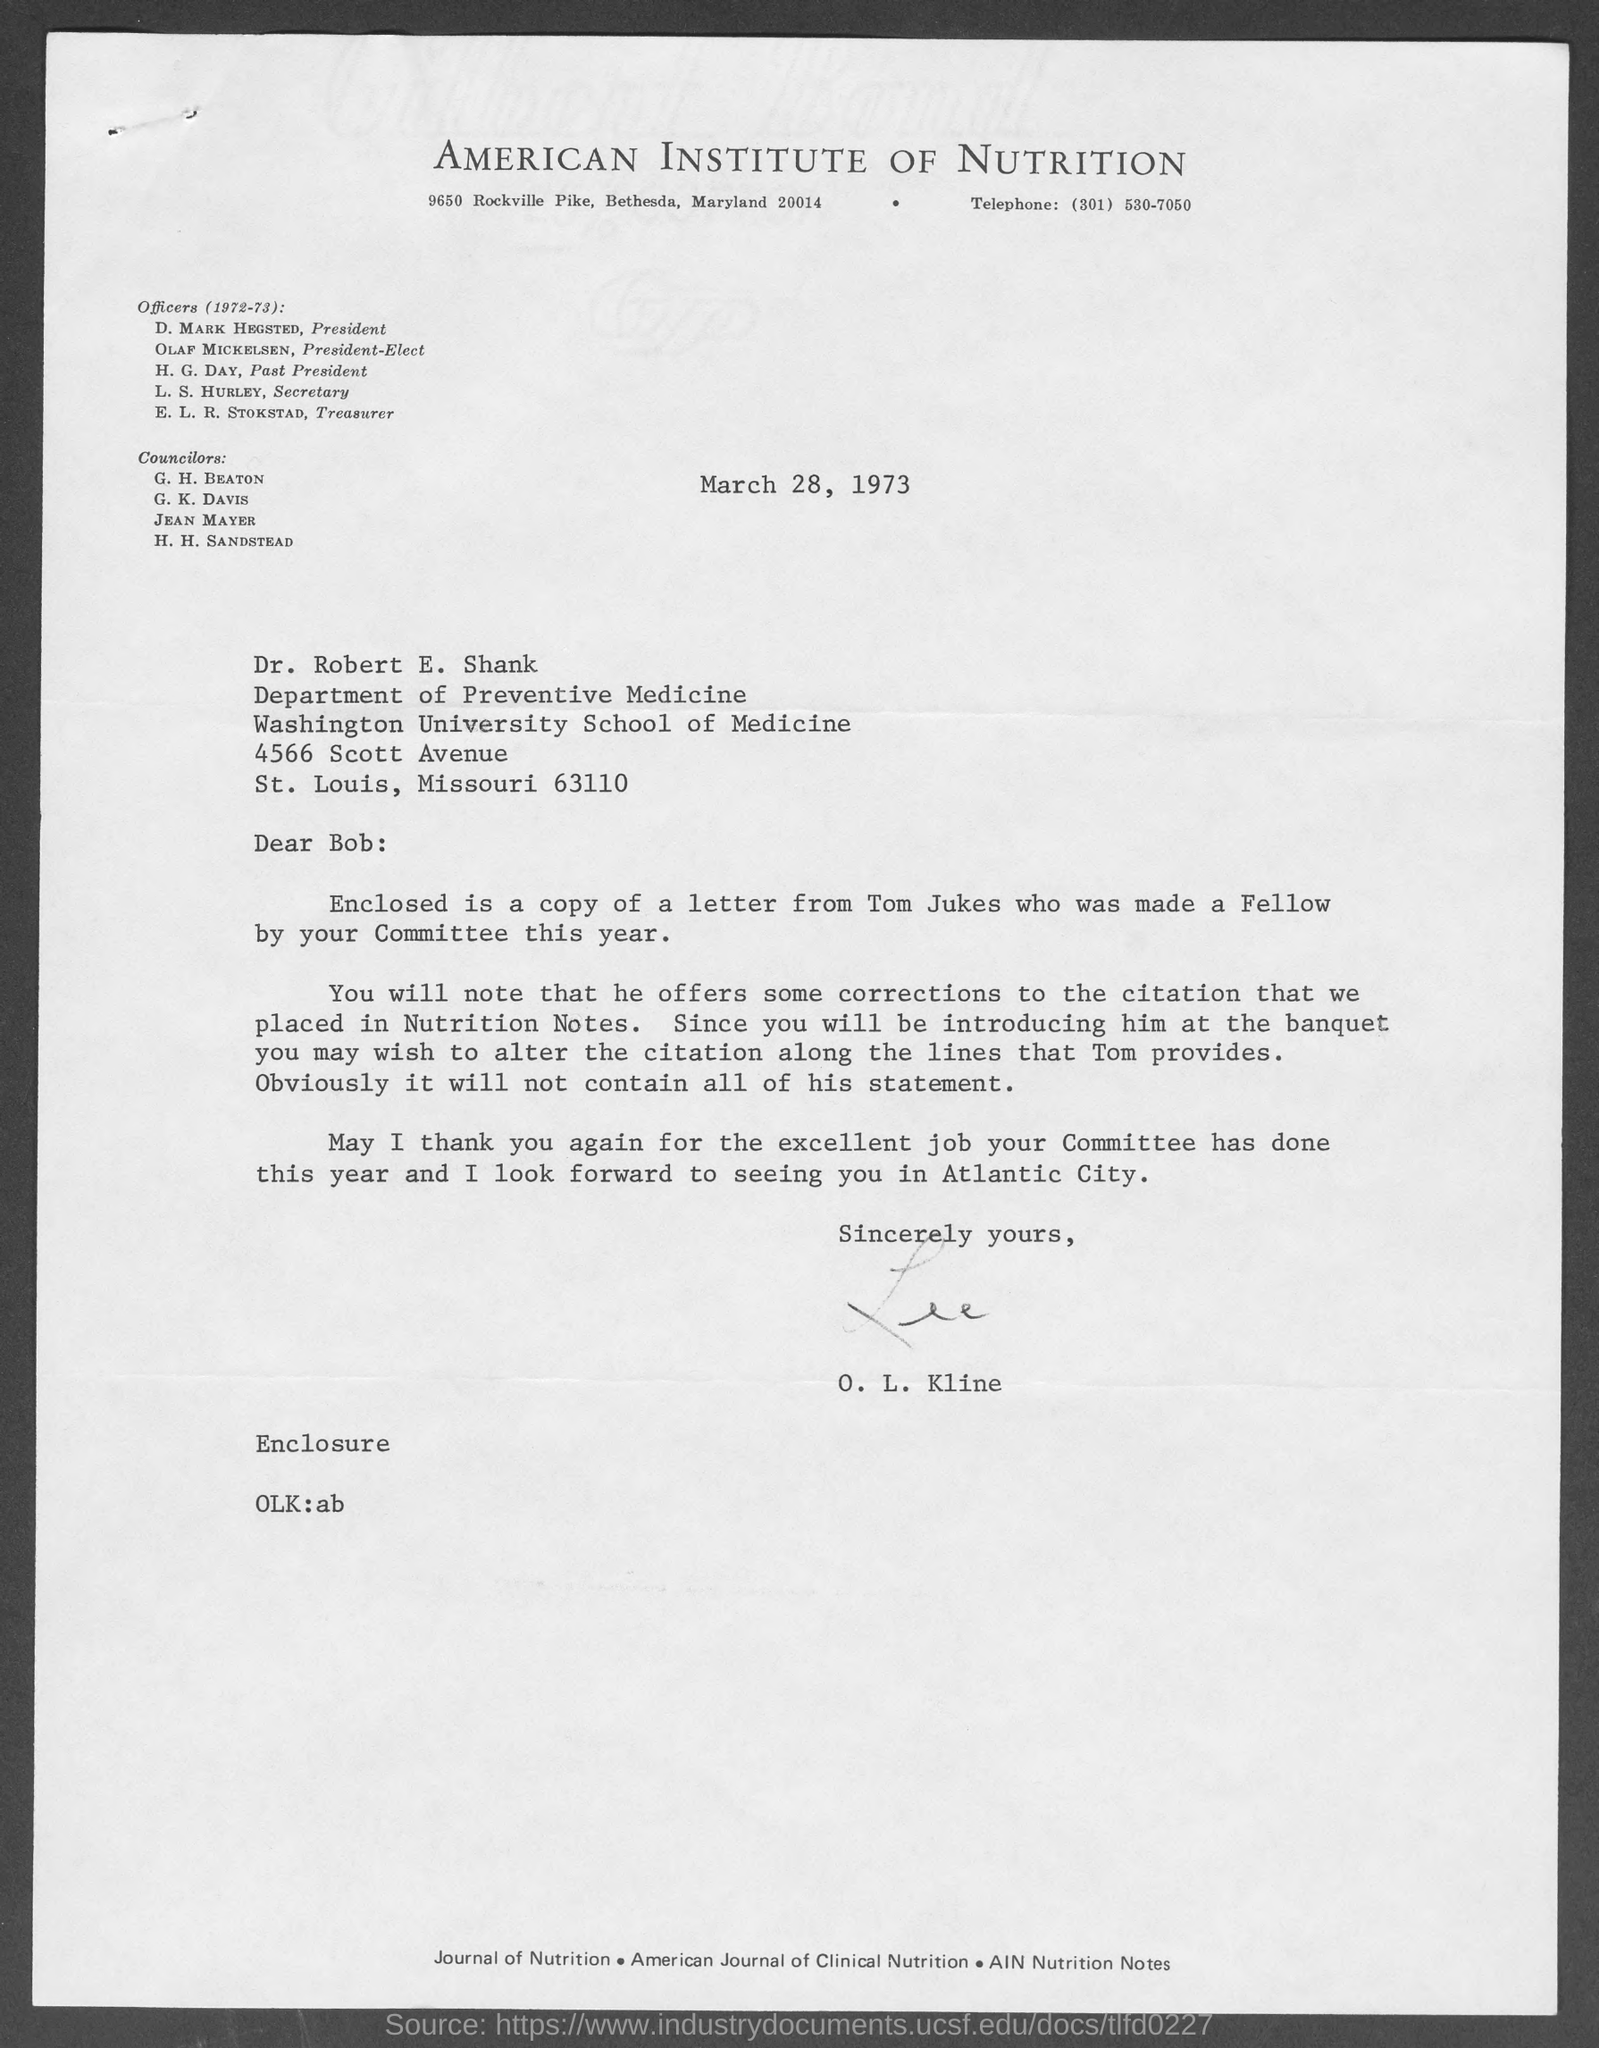Who is president of the american institute of nutrition?
Provide a short and direct response. D. Mark Hegsted. Who is the president- elect of the american institute of nutrition?
Provide a succinct answer. Olaf Mickelsen. Who is the past president of the american institute of nutrition ?
Ensure brevity in your answer.  H. G. Day. 